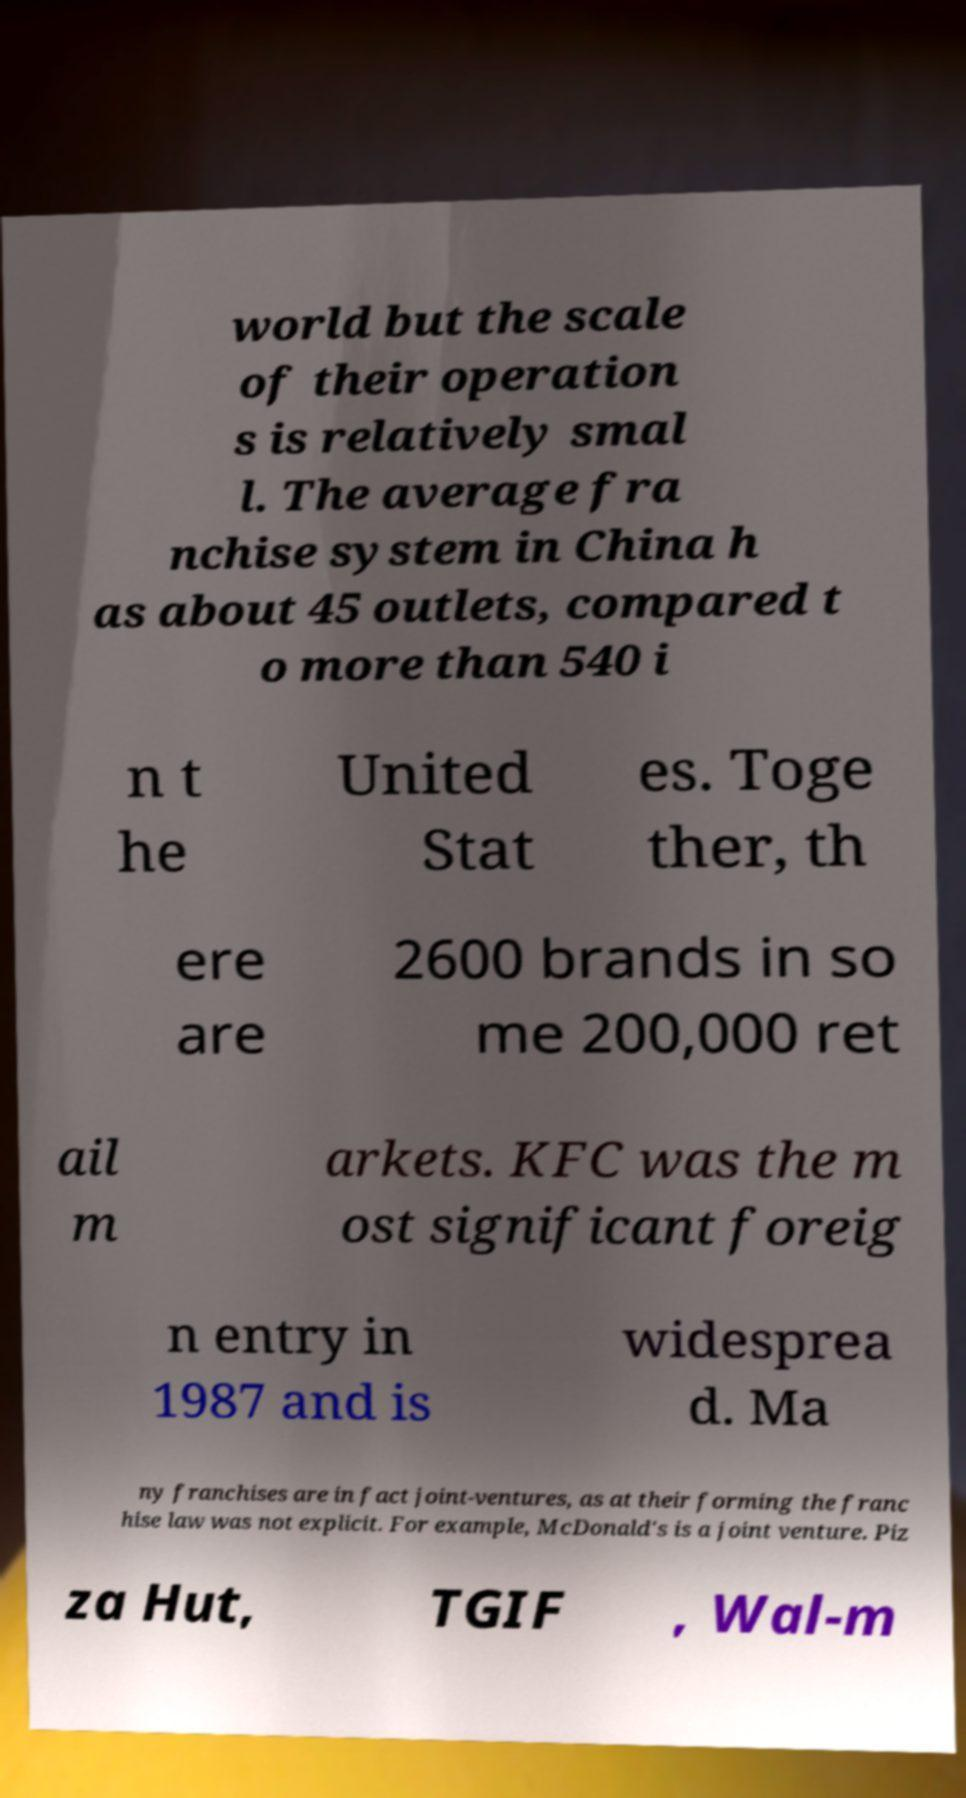Could you assist in decoding the text presented in this image and type it out clearly? world but the scale of their operation s is relatively smal l. The average fra nchise system in China h as about 45 outlets, compared t o more than 540 i n t he United Stat es. Toge ther, th ere are 2600 brands in so me 200,000 ret ail m arkets. KFC was the m ost significant foreig n entry in 1987 and is widesprea d. Ma ny franchises are in fact joint-ventures, as at their forming the franc hise law was not explicit. For example, McDonald's is a joint venture. Piz za Hut, TGIF , Wal-m 